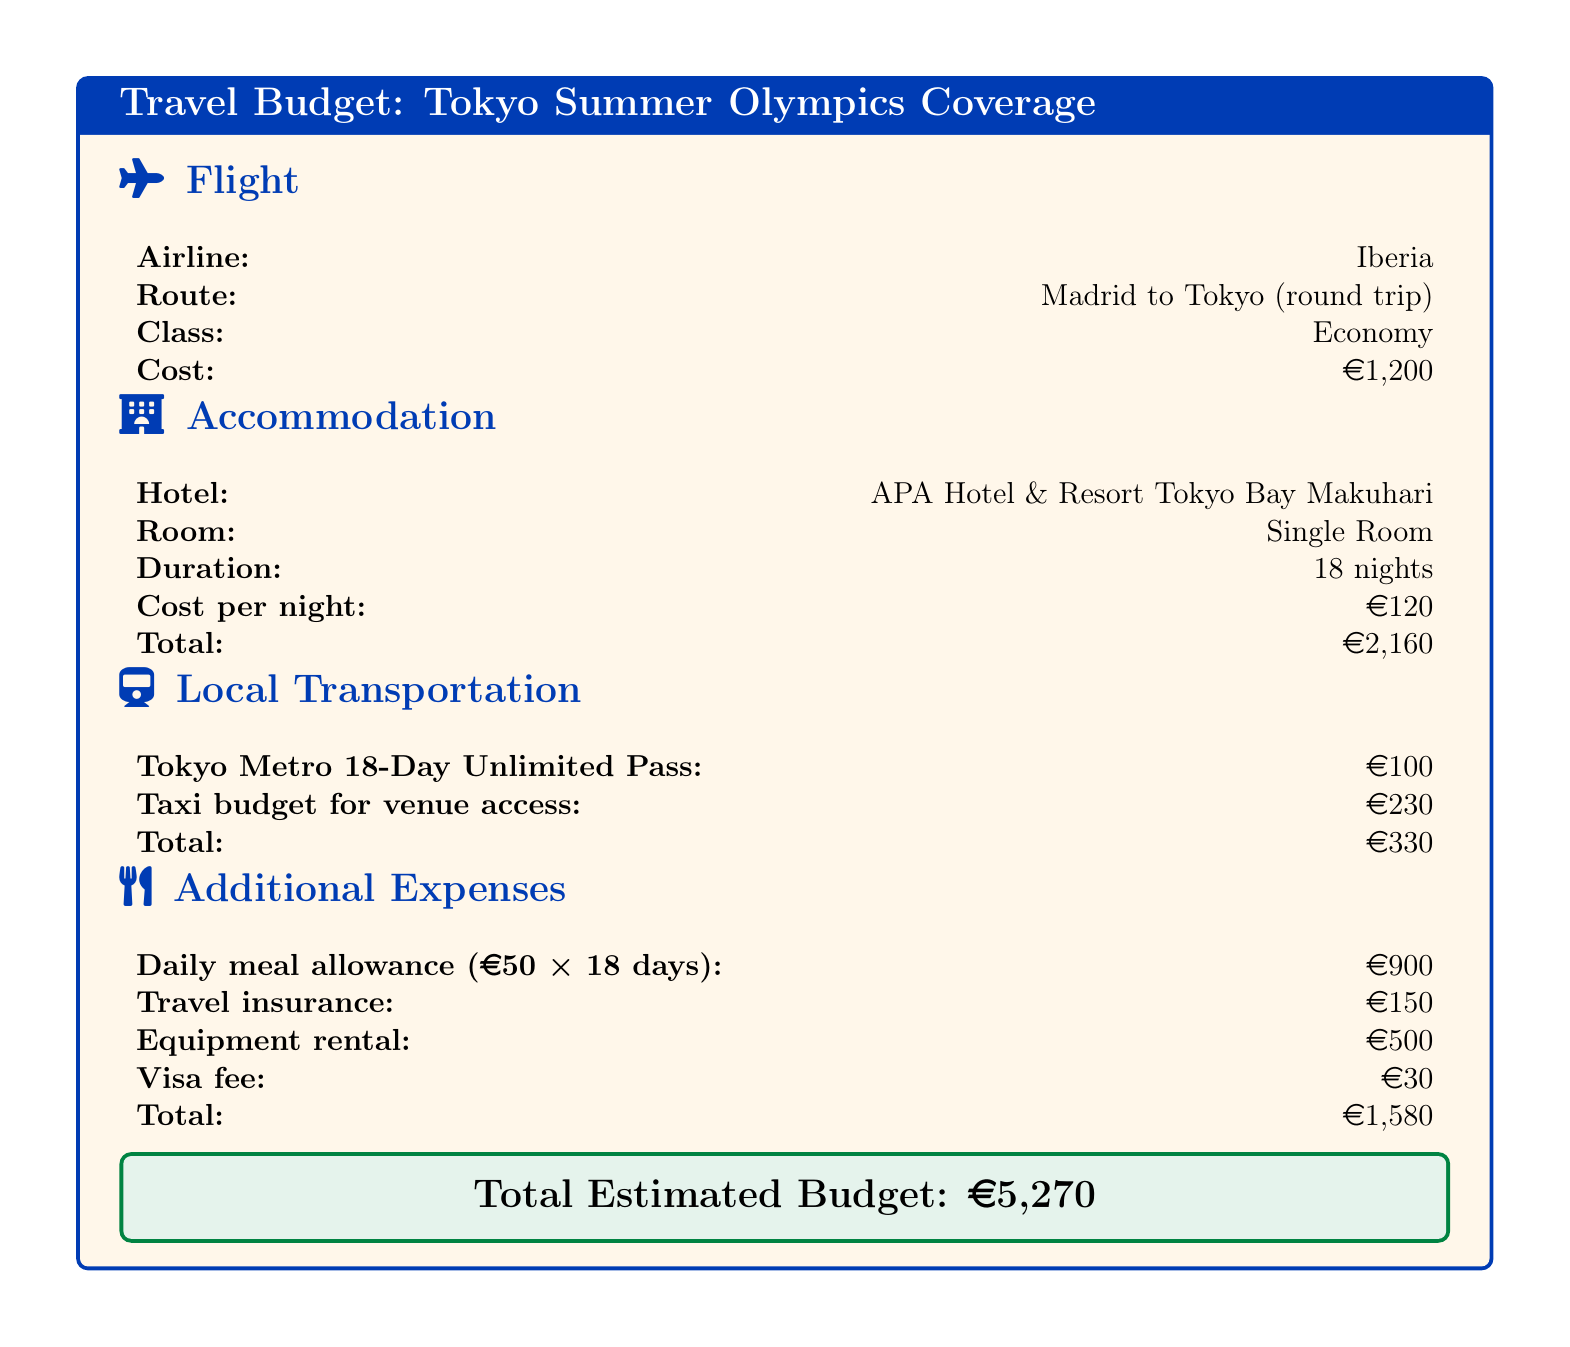What is the cost of the round trip flight? The cost of the round trip flight from Madrid to Tokyo is specifically stated in the document.
Answer: 1,200 euros How many nights will the accommodation last? The document mentions the duration of the stay in the hotel specified for the coverage.
Answer: 18 nights What is the total cost for local transportation? The total cost for local transportation is the sum of the individual transportation expenses listed in the document.
Answer: 330 euros What is the daily meal allowance per day? The document specifies the daily meal allowance that is applied over the duration of the stay.
Answer: 50 euros Which hotel will be used for accommodation? The name of the hotel selected for the stay during the Olympics is stated clearly in the document.
Answer: APA Hotel & Resort Tokyo Bay Makuhari How much is the total estimated budget? The document concludes with a summary of the overall budget for the trip, which includes all expenses listed.
Answer: 5,270 euros What type of room is booked at the hotel? The document provides specific information about the type of room booked for accommodation during the stay.
Answer: Single Room What is the cost of the travel insurance? The travel insurance cost is specified in the additional expenses section of the document.
Answer: 150 euros How much is the taxi budget for venue access? The specific amount allocated for taxi transportation to access the venues is mentioned in the local transportation section.
Answer: 230 euros 